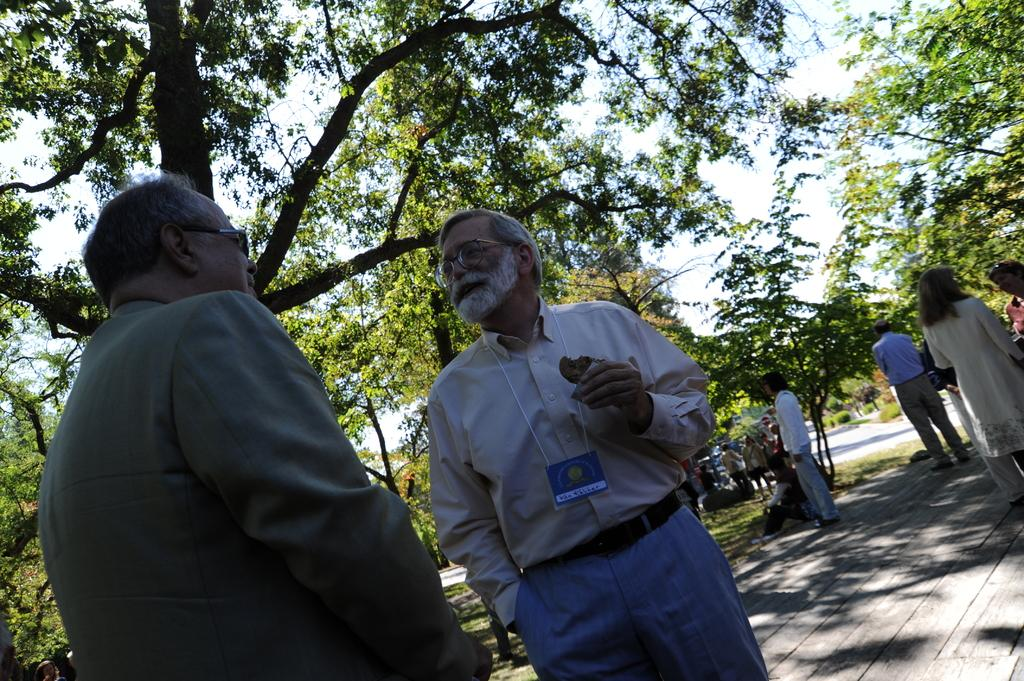What is happening on the road in the image? There are people on the road in the image. What can be seen around the road in the image? There are trees around the road in the image. What type of vegetation is visible in the image? There is grass visible in the image. How many eggs are visible in the image? There are no eggs present in the image. What type of view can be seen from the road in the image? The provided facts do not mention a view or any specific scenery visible from the road. 